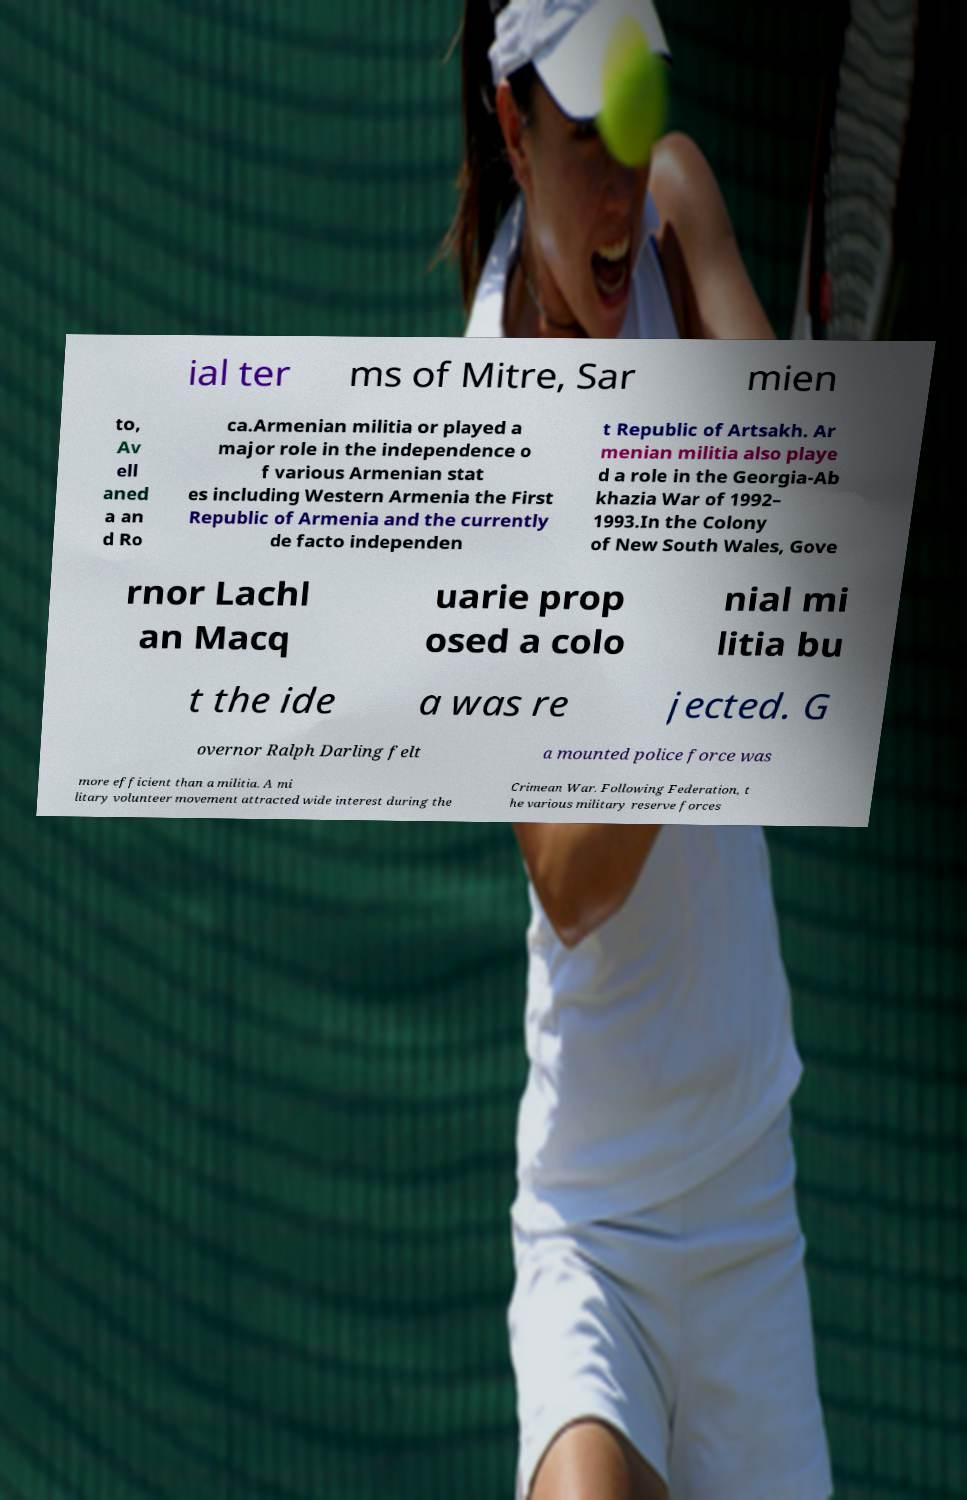What messages or text are displayed in this image? I need them in a readable, typed format. ial ter ms of Mitre, Sar mien to, Av ell aned a an d Ro ca.Armenian militia or played a major role in the independence o f various Armenian stat es including Western Armenia the First Republic of Armenia and the currently de facto independen t Republic of Artsakh. Ar menian militia also playe d a role in the Georgia-Ab khazia War of 1992– 1993.In the Colony of New South Wales, Gove rnor Lachl an Macq uarie prop osed a colo nial mi litia bu t the ide a was re jected. G overnor Ralph Darling felt a mounted police force was more efficient than a militia. A mi litary volunteer movement attracted wide interest during the Crimean War. Following Federation, t he various military reserve forces 